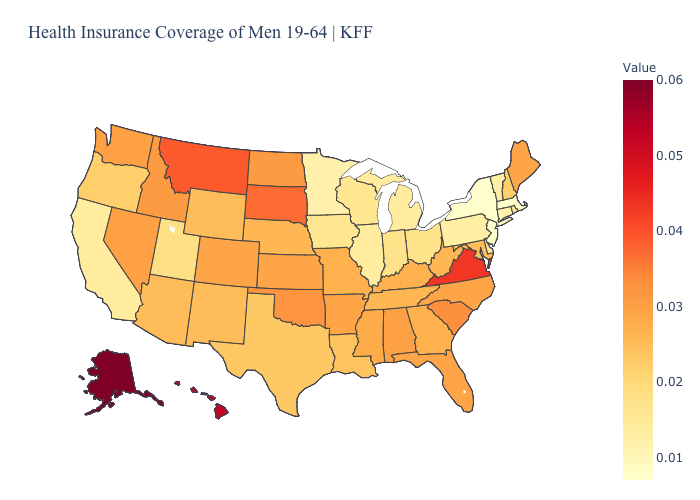Which states have the lowest value in the USA?
Short answer required. Massachusetts, New Jersey, New York. Does the map have missing data?
Give a very brief answer. No. Does Alaska have the highest value in the West?
Quick response, please. Yes. 